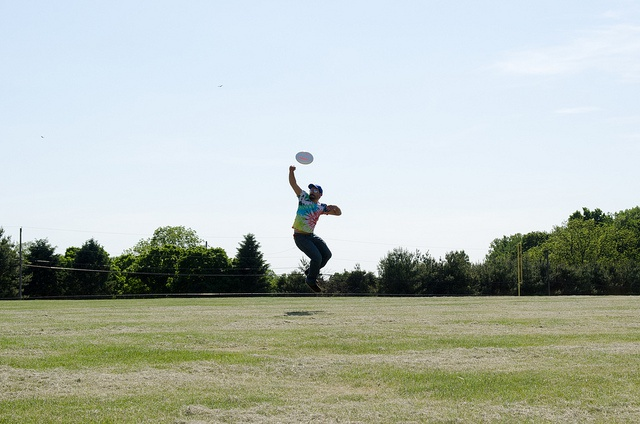Describe the objects in this image and their specific colors. I can see people in lavender, black, gray, maroon, and teal tones and frisbee in lavender, gray, and lightgray tones in this image. 